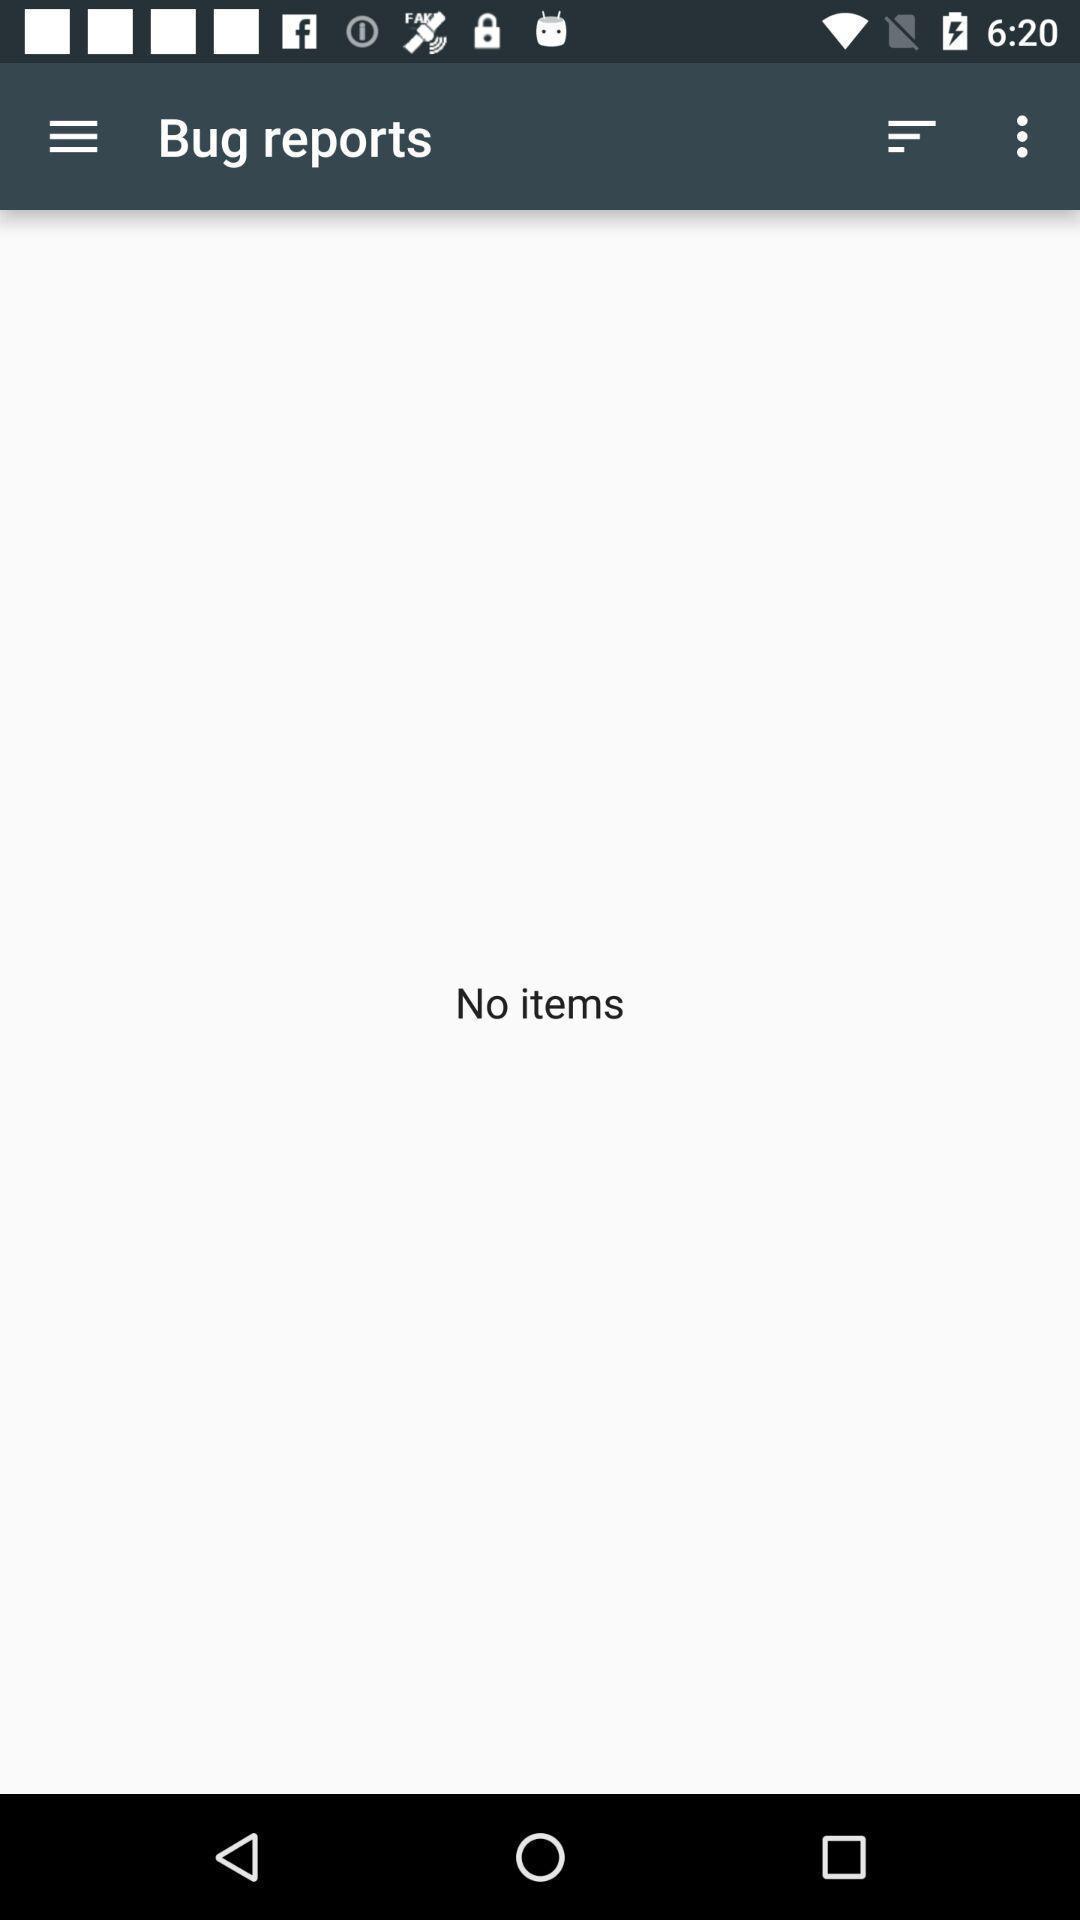What is the overall content of this screenshot? Screen showing blank page in bug report tab. 